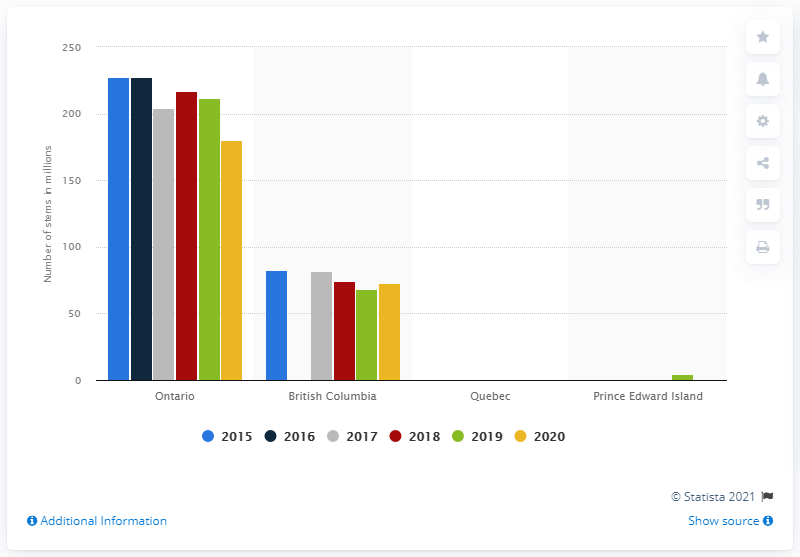Indicate a few pertinent items in this graphic. In 2020, a total of 180.52 million cut flowers were produced in Ontario. 